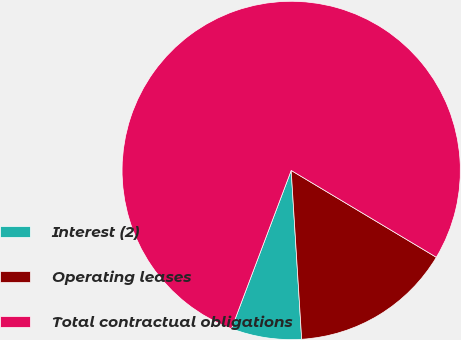Convert chart to OTSL. <chart><loc_0><loc_0><loc_500><loc_500><pie_chart><fcel>Interest (2)<fcel>Operating leases<fcel>Total contractual obligations<nl><fcel>6.73%<fcel>15.43%<fcel>77.84%<nl></chart> 